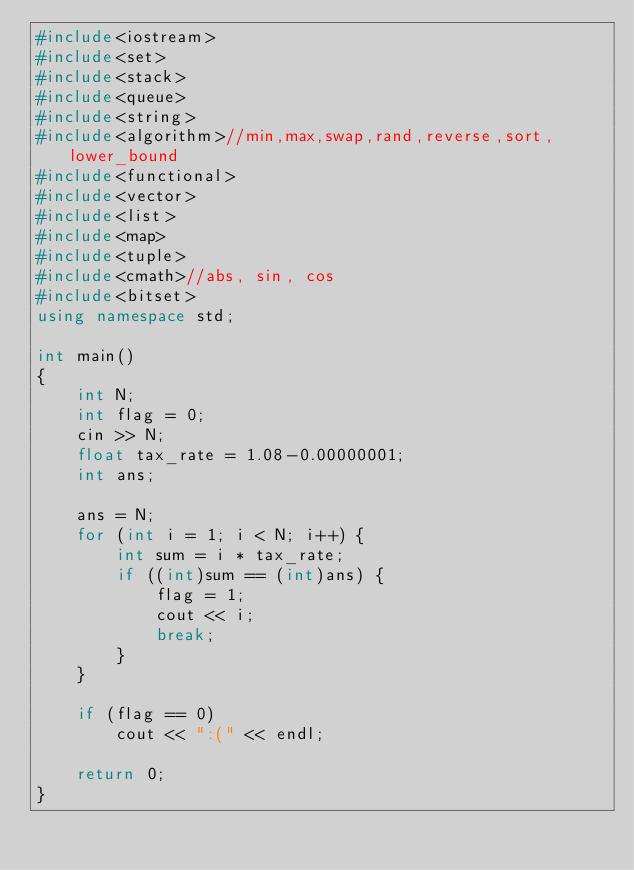<code> <loc_0><loc_0><loc_500><loc_500><_C++_>#include<iostream>
#include<set>
#include<stack>
#include<queue>
#include<string>
#include<algorithm>//min,max,swap,rand,reverse,sort,lower_bound
#include<functional>
#include<vector>
#include<list>
#include<map>
#include<tuple>
#include<cmath>//abs, sin, cos
#include<bitset>
using namespace std;

int main()
{
	int N;
	int flag = 0;
	cin >> N;
	float tax_rate = 1.08-0.00000001;
	int ans;

	ans = N;
	for (int i = 1; i < N; i++) {
		int sum = i * tax_rate;
		if ((int)sum == (int)ans) {
			flag = 1;
			cout << i;
			break;
		}
	}

	if (flag == 0)
		cout << ":(" << endl;

	return 0;
}</code> 